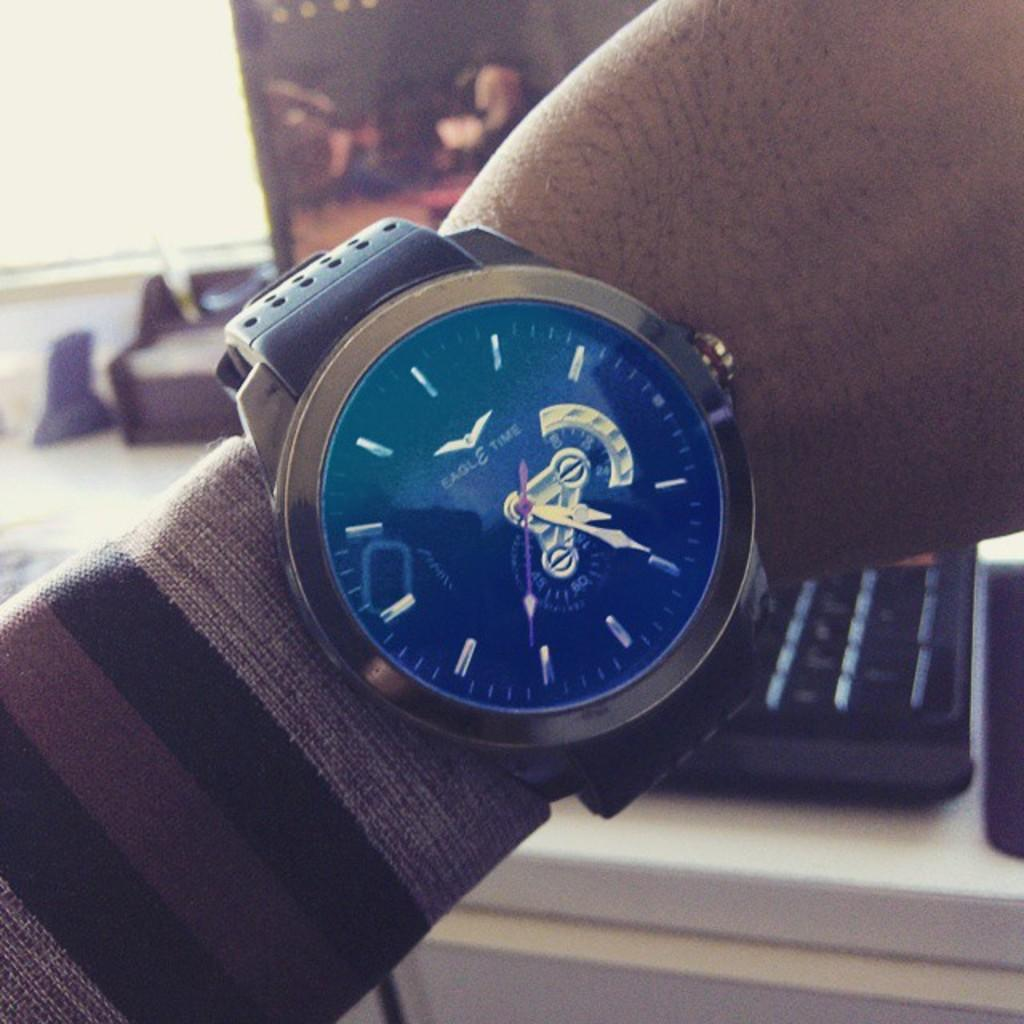<image>
Relay a brief, clear account of the picture shown. Eagle Time metallic men's watch with perforated leather bands and winding button on side for face with no numerals, only dashes. 